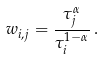<formula> <loc_0><loc_0><loc_500><loc_500>w _ { i , j } = \frac { \tau _ { j } ^ { \alpha } } { \tau _ { i } ^ { 1 - \alpha } } \, .</formula> 